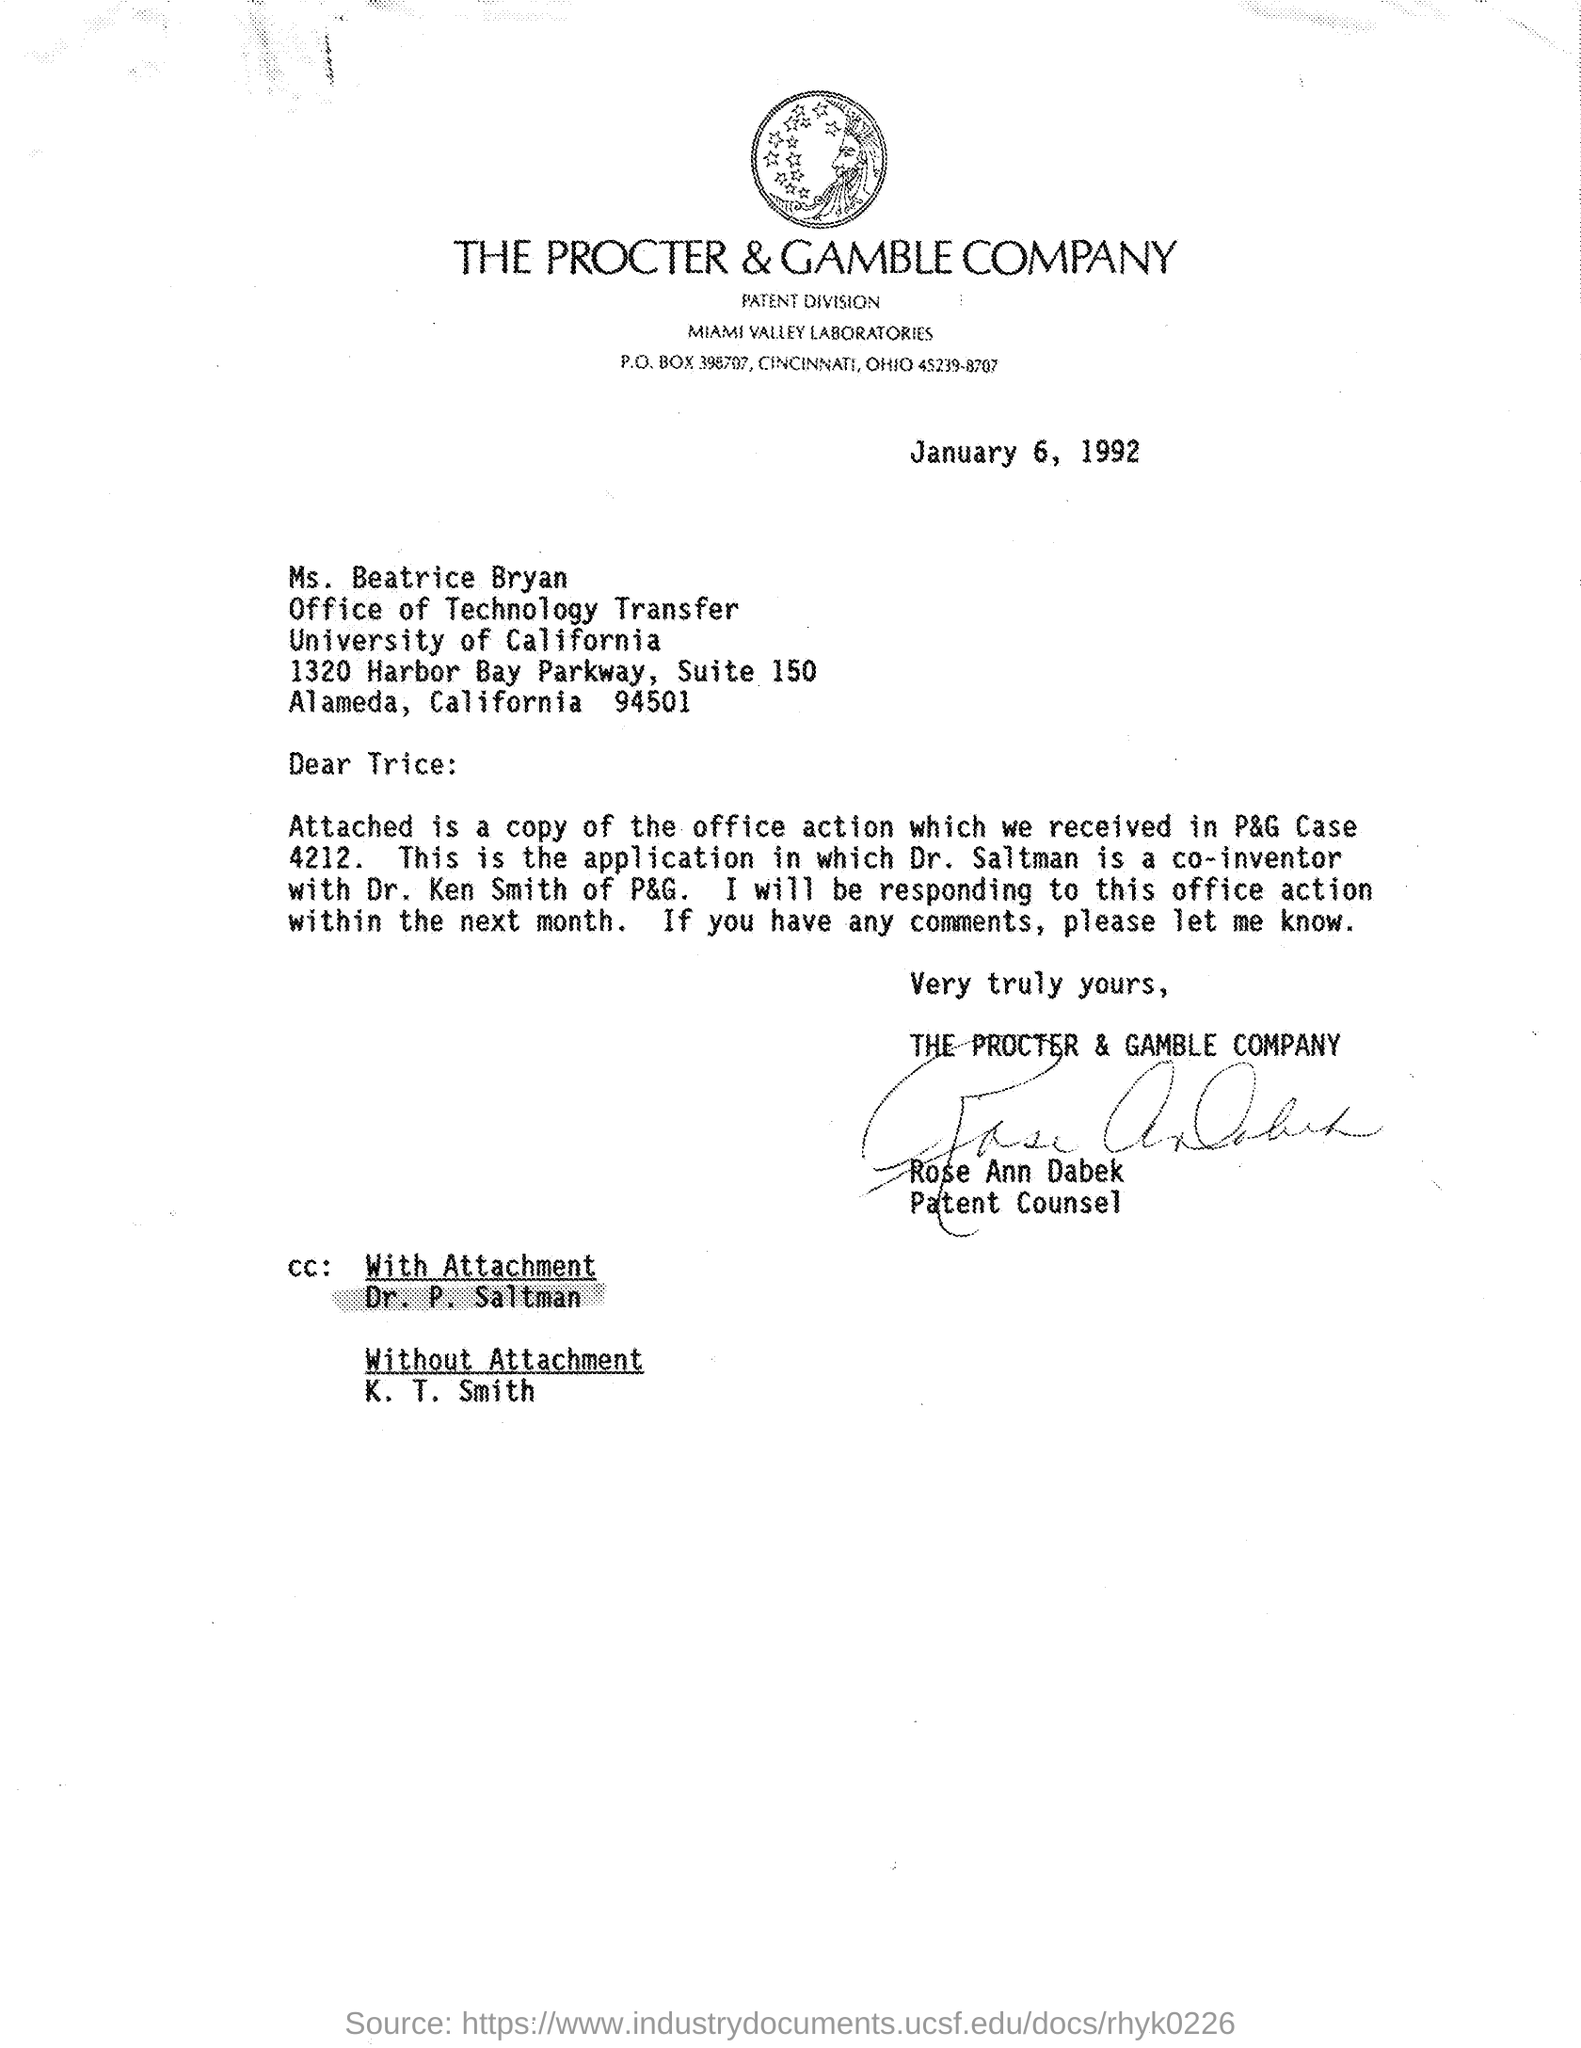Indicate a few pertinent items in this graphic. The date mentioned is January 6, 1992. Dr. P. Saltman is mentioned in the CC with attachment. K. T. Smith is mentioned in the CC without attachment. 